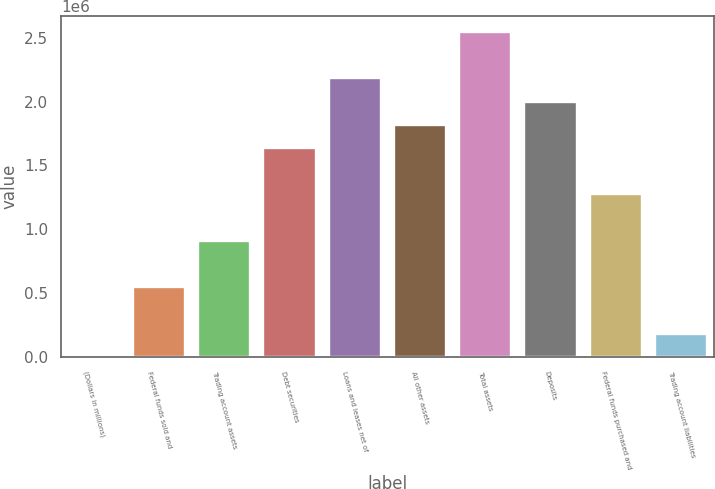Convert chart. <chart><loc_0><loc_0><loc_500><loc_500><bar_chart><fcel>(Dollars in millions)<fcel>Federal funds sold and<fcel>Trading account assets<fcel>Debt securities<fcel>Loans and leases net of<fcel>All other assets<fcel>Total assets<fcel>Deposits<fcel>Federal funds purchased and<fcel>Trading account liabilities<nl><fcel>2008<fcel>546788<fcel>909976<fcel>1.63635e+06<fcel>2.18113e+06<fcel>1.81794e+06<fcel>2.54432e+06<fcel>1.99954e+06<fcel>1.27316e+06<fcel>183602<nl></chart> 